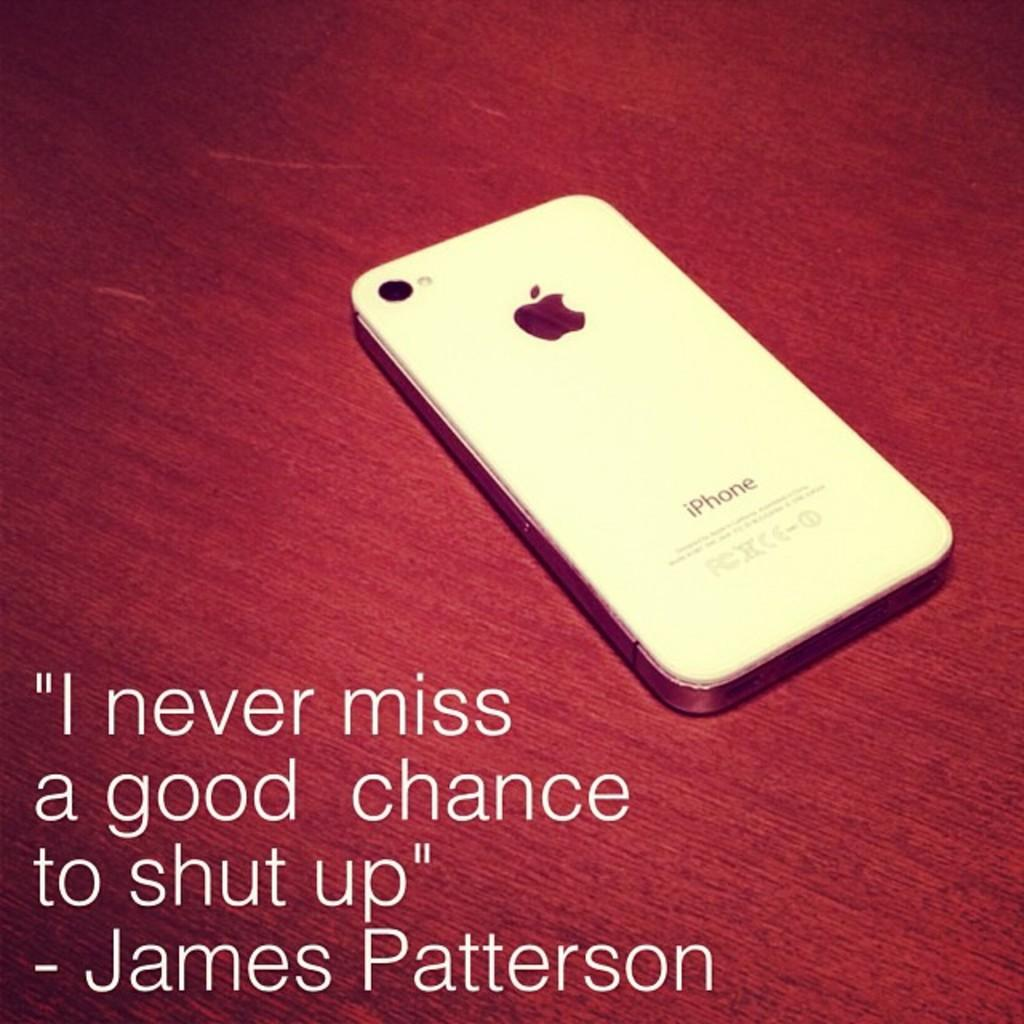<image>
Describe the image concisely. An Apple Iphone lying on a maroon table with James Patterson print in the foreground. 